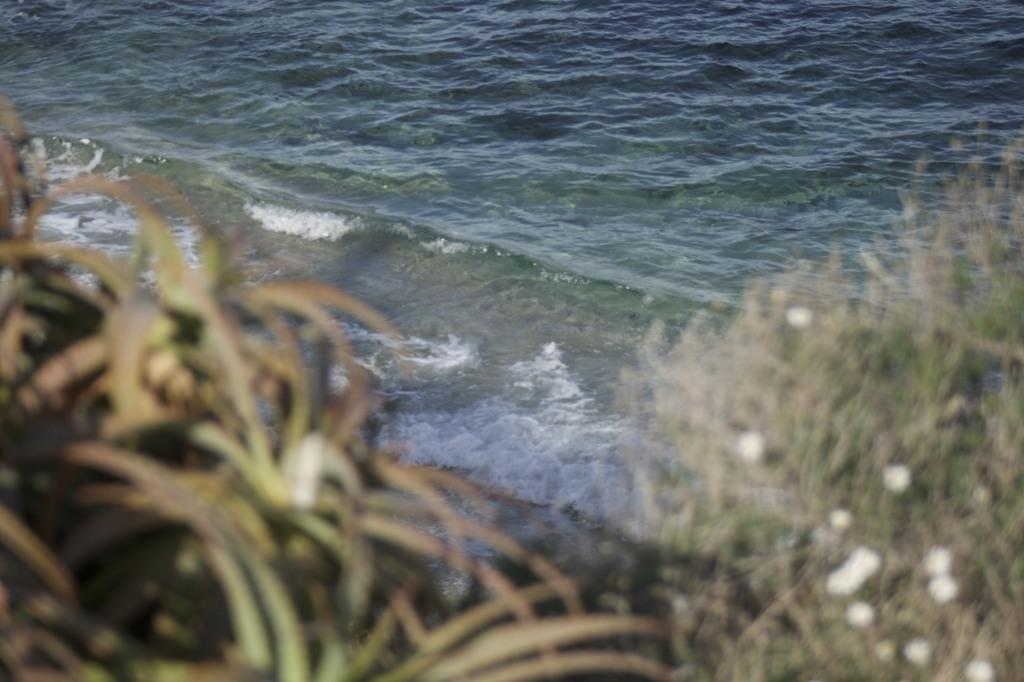What type of living organisms can be seen in the image? Plants can be seen in the image. What is the primary element visible in the image? Water is visible in the image. What type of farmer is working in the town depicted in the image? There is no town or farmer present in the image; it only features plants and water. 